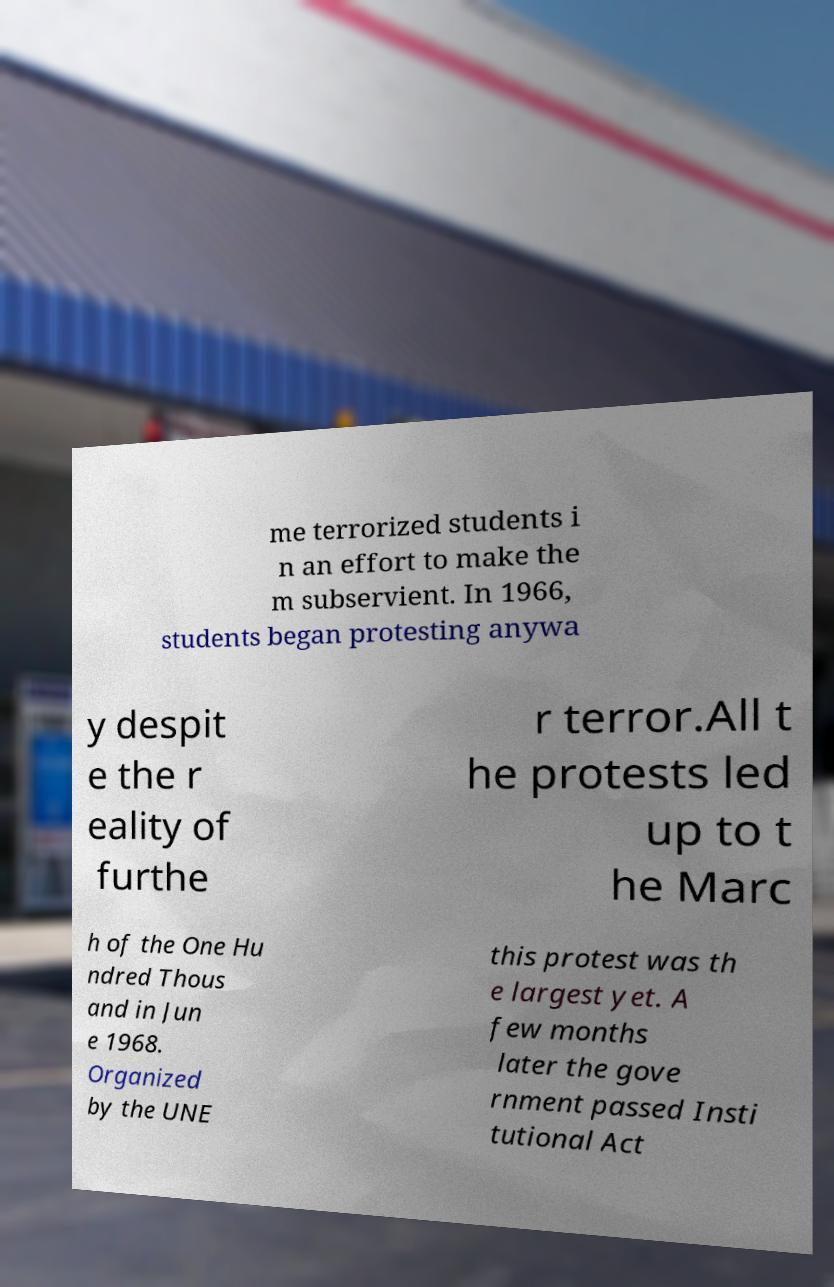For documentation purposes, I need the text within this image transcribed. Could you provide that? me terrorized students i n an effort to make the m subservient. In 1966, students began protesting anywa y despit e the r eality of furthe r terror.All t he protests led up to t he Marc h of the One Hu ndred Thous and in Jun e 1968. Organized by the UNE this protest was th e largest yet. A few months later the gove rnment passed Insti tutional Act 